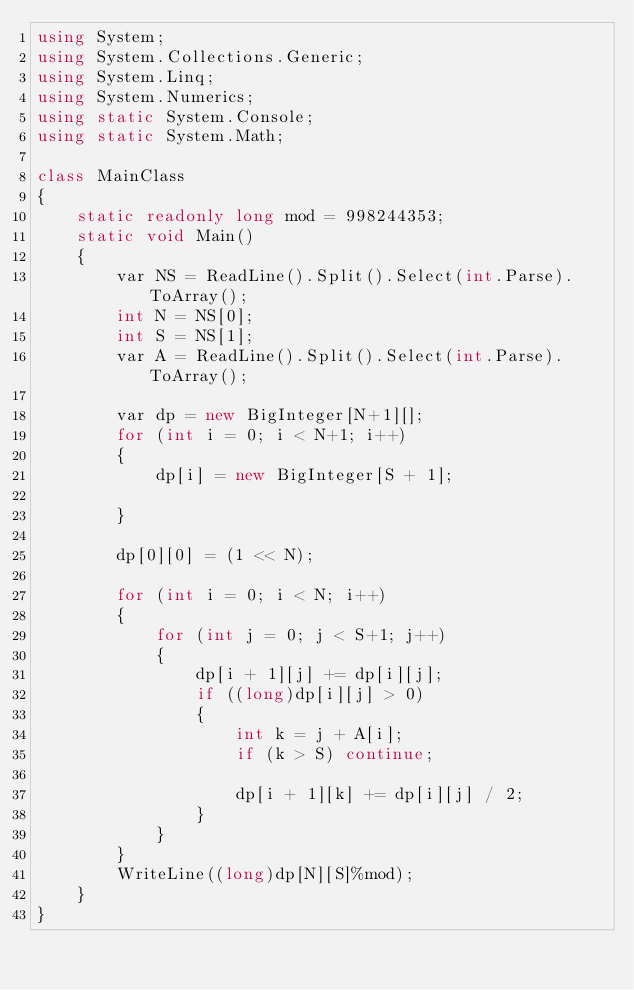Convert code to text. <code><loc_0><loc_0><loc_500><loc_500><_C#_>using System;
using System.Collections.Generic;
using System.Linq;
using System.Numerics;
using static System.Console;
using static System.Math;

class MainClass
{
    static readonly long mod = 998244353;
    static void Main()
    {
        var NS = ReadLine().Split().Select(int.Parse).ToArray();
        int N = NS[0];
        int S = NS[1];
        var A = ReadLine().Split().Select(int.Parse).ToArray();

        var dp = new BigInteger[N+1][];
        for (int i = 0; i < N+1; i++)
        {
            dp[i] = new BigInteger[S + 1];
            
        }

        dp[0][0] = (1 << N);

        for (int i = 0; i < N; i++)
        {
            for (int j = 0; j < S+1; j++)
            {
                dp[i + 1][j] += dp[i][j];
                if ((long)dp[i][j] > 0)
                {
                    int k = j + A[i];
                    if (k > S) continue;
                    
                    dp[i + 1][k] += dp[i][j] / 2;
                }
            }
        }
        WriteLine((long)dp[N][S]%mod);
    }
}
</code> 